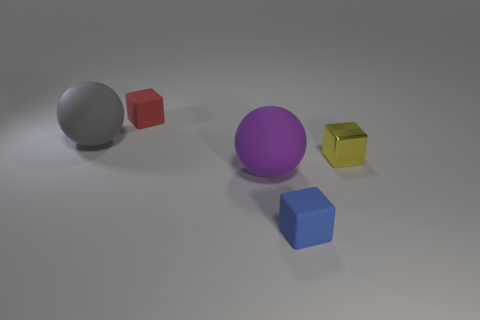What number of objects are tiny rubber objects to the left of the blue matte block or small brown matte cubes?
Your answer should be very brief. 1. Is there a big purple thing?
Offer a very short reply. Yes. There is a large object that is on the right side of the tiny red object; what is its material?
Your answer should be compact. Rubber. How many large things are either blue cubes or green matte objects?
Provide a short and direct response. 0. What color is the metal block?
Your response must be concise. Yellow. Are there any small shiny blocks that are to the left of the block that is to the right of the blue block?
Give a very brief answer. No. Are there fewer yellow cubes that are in front of the yellow metallic object than blue shiny spheres?
Your response must be concise. No. Does the big gray ball behind the small yellow thing have the same material as the tiny blue thing?
Ensure brevity in your answer.  Yes. What color is the other tiny cube that is made of the same material as the red cube?
Your response must be concise. Blue. Is the number of small blocks on the right side of the tiny blue matte block less than the number of tiny yellow blocks in front of the tiny yellow metallic cube?
Offer a terse response. No. 